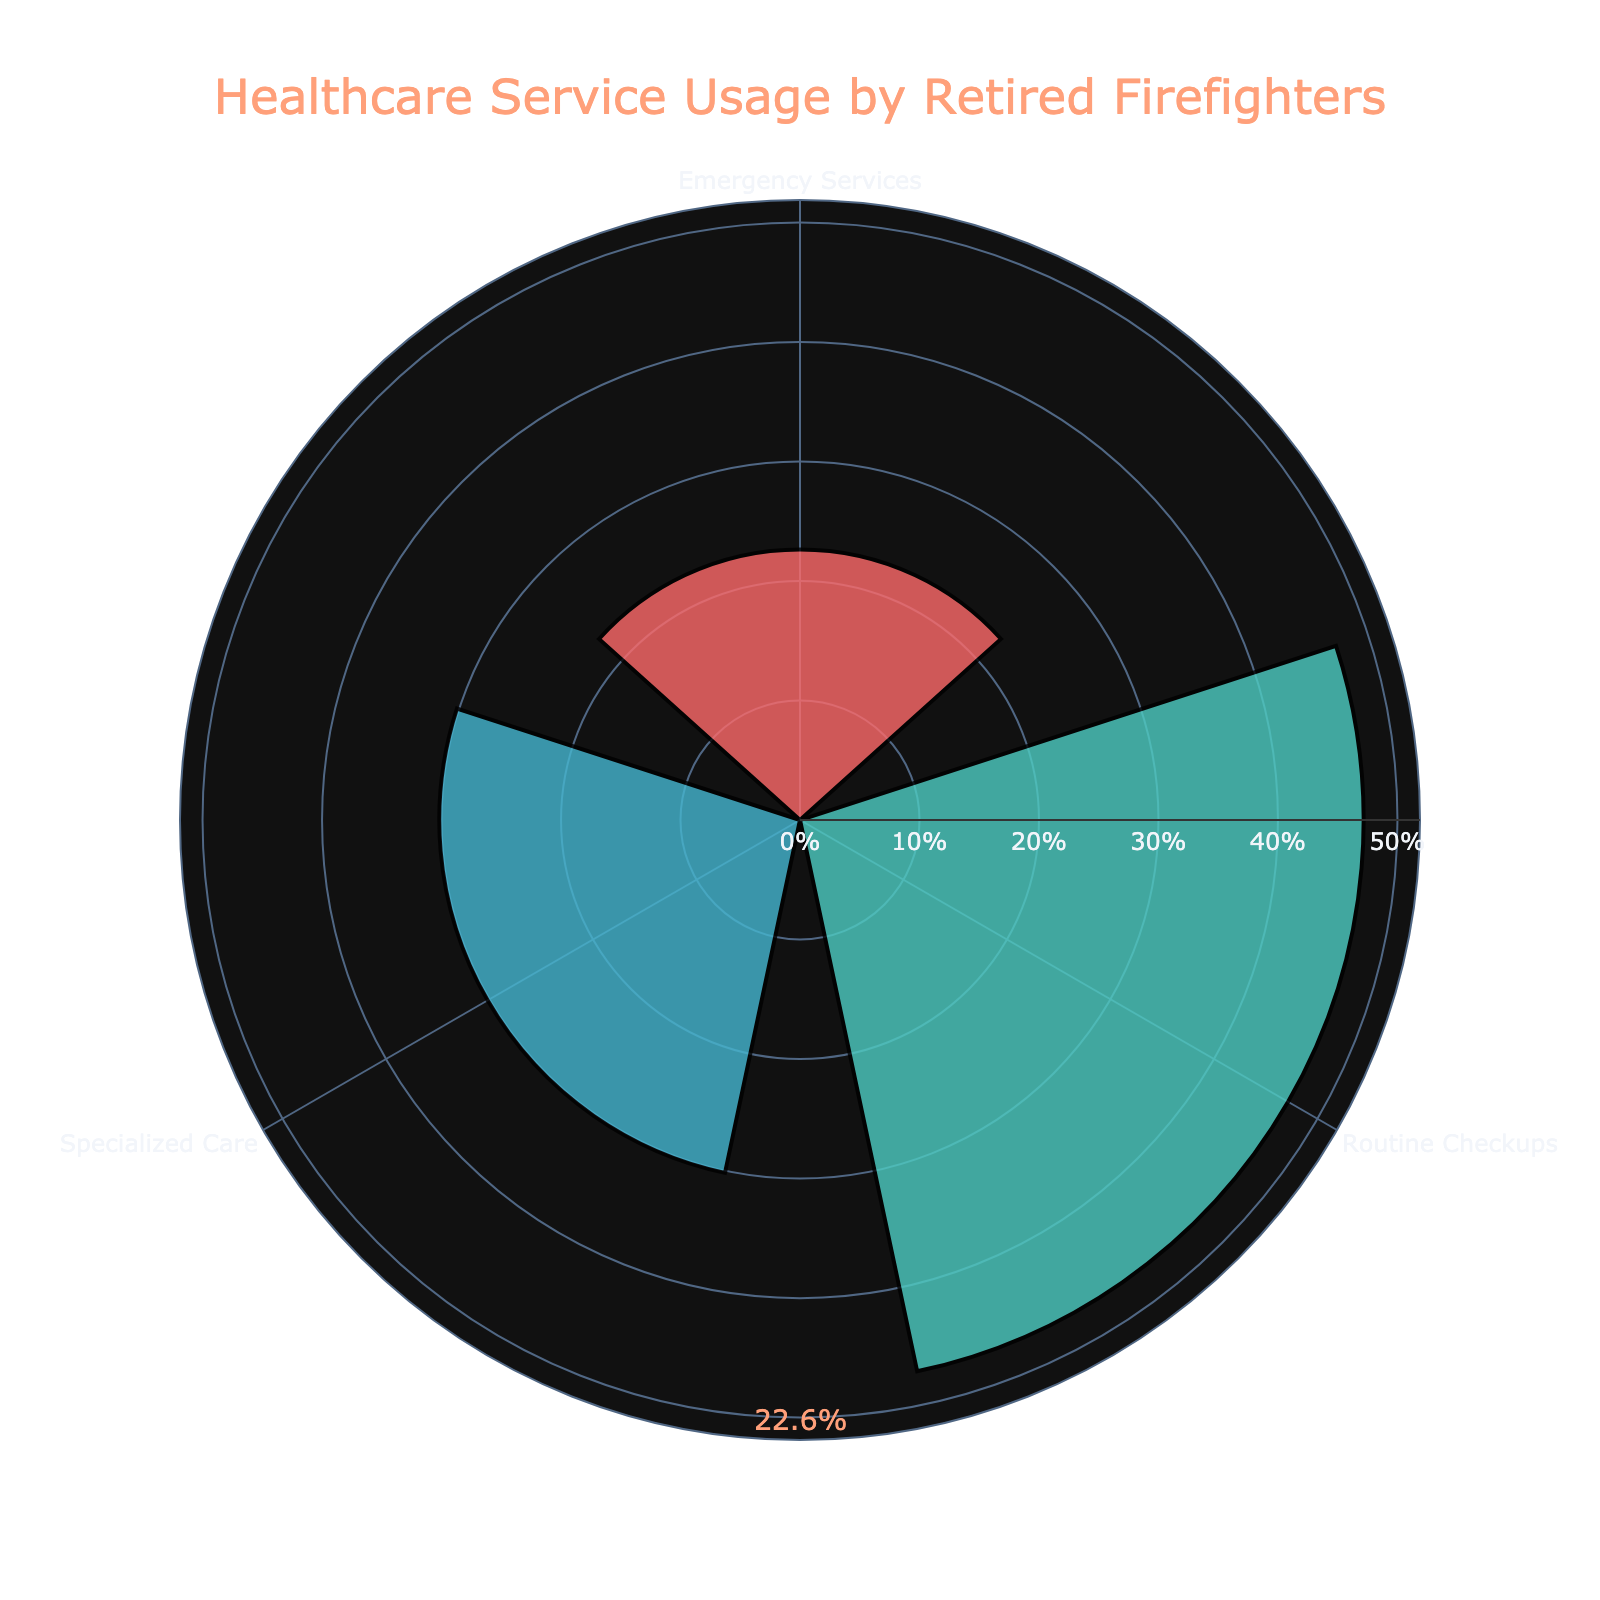What is the title of the figure? The title is usually displayed at the top of the figure. In this case, it states "Healthcare Service Usage by Retired Firefighters".
Answer: Healthcare Service Usage by Retired Firefighters What color represents Routine Checkups in the chart? The rose chart uses different colors to distinguish service types. The usage of Routine Checkups is represented by a teal color.
Answer: Teal Which service type has the highest usage percentage? By examining the radial lengths, we can see that Routine Checkups have the longest bar, hence the highest usage percentage.
Answer: Routine Checkups How do the percentages of Specialized Care services (Respiratory and Cardiovascular) compare to Routine Checkups? Routine Checkups have a percentage higher than the combined total of Specialized Care for both Respiratory and Cardiovascular as its bar length is noticeably longer than the sum of the bars for the specialized services.
Answer: Routine Checkups > Specialized Care (Respiratory + Cardiovascular) What is the approximate percentage of Emergency Services usage? By looking at the annotated percentage labels, Emergency Services are approximately at 24%.
Answer: 24% Calculate the total percentage of Specialized Care services by adding Respiratory and Cardiovascular care percentages. Individual percentages are combined for total specialization care: 18% (Respiratory) + 14% (Cardiovascular).
Answer: 32% Which service type shows the lowest percentage of usage? By identifying the shortest bar on the chart, specialized Cardiovascular Care has the lowest percentage.
Answer: Specialized Care (Cardiovascular) What is the difference in percentage between Emergency Services and Routine Checkups? The percentage for Emergency Services is 24%, and for Routine Checkups, it is 51%. Subtracting 24 from 51 gives us the difference.
Answer: 27% How many service types are displayed on the chart? Each distinct bar represents a different service type. Counting these bars gives the total number of service types.
Answer: 3 Is the percentage of Routine Checkups greater than the combined percentage of Emergency Services and Specialized Care (Respiratory)? Routine Checkups have a percentage of 51%. The combined percentage of Emergency Services (24%) and Specialized Care (Respiratory) (18%) is 42%, which is less than 51%.
Answer: Yes, it is greater 